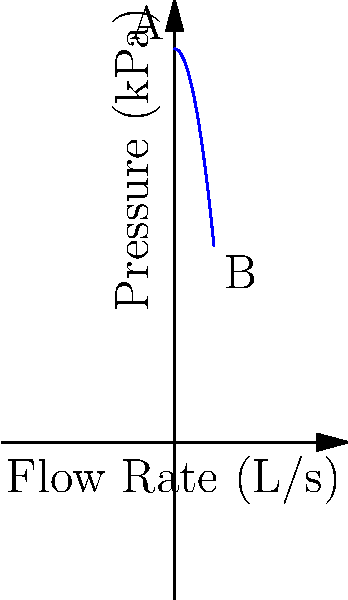In a water distribution system, the pressure decreases as the flow rate increases, as shown in the graph. If the initial pressure at point A is 100 kPa and the pressure drops to 50 kPa at point B with a flow rate of 10 L/s, what is the flow rate when the pressure is 75 kPa? To solve this problem, we'll follow these steps:

1. Identify the relationship between pressure and flow rate:
   The graph shows a quadratic relationship, where pressure decreases as flow rate increases.

2. Determine the equation of the curve:
   We can use the general form of a quadratic equation: $P = a(Q^2) + bQ + c$
   Where $P$ is pressure and $Q$ is flow rate.

3. Use the given points to find the equation:
   Point A: $(0, 100)$, so $c = 100$
   Point B: $(10, 50)$

4. Substitute values into the equation:
   $50 = a(10^2) + b(10) + 100$
   $50 = 100a + 10b + 100$
   $-50 = 100a + 10b$

5. Since we only have one equation with two unknowns, we can assume $b = 0$ for simplicity:
   $-50 = 100a$
   $a = -0.5$

6. The equation of the curve is:
   $P = -0.5Q^2 + 100$

7. To find the flow rate when pressure is 75 kPa, substitute $P = 75$:
   $75 = -0.5Q^2 + 100$
   $-25 = -0.5Q^2$
   $Q^2 = 50$
   $Q = \sqrt{50} \approx 7.07$ L/s

Therefore, the flow rate when the pressure is 75 kPa is approximately 7.07 L/s.
Answer: 7.07 L/s 